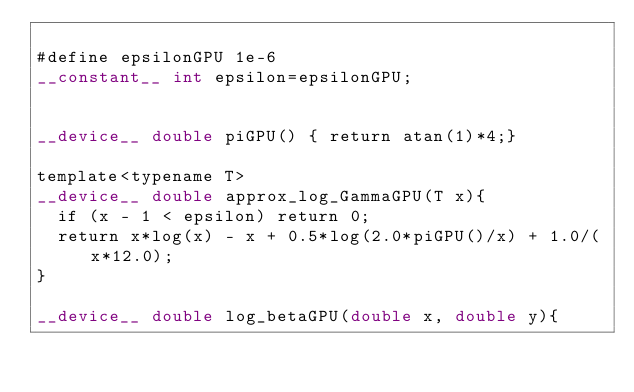Convert code to text. <code><loc_0><loc_0><loc_500><loc_500><_Cuda_>
#define epsilonGPU 1e-6
__constant__ int epsilon=epsilonGPU;


__device__ double piGPU() { return atan(1)*4;}

template<typename T>
__device__ double approx_log_GammaGPU(T x){
	if (x - 1 < epsilon) return 0;
	return x*log(x) - x + 0.5*log(2.0*piGPU()/x) + 1.0/(x*12.0);
}

__device__ double log_betaGPU(double x, double y){</code> 